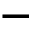<formula> <loc_0><loc_0><loc_500><loc_500>-</formula> 